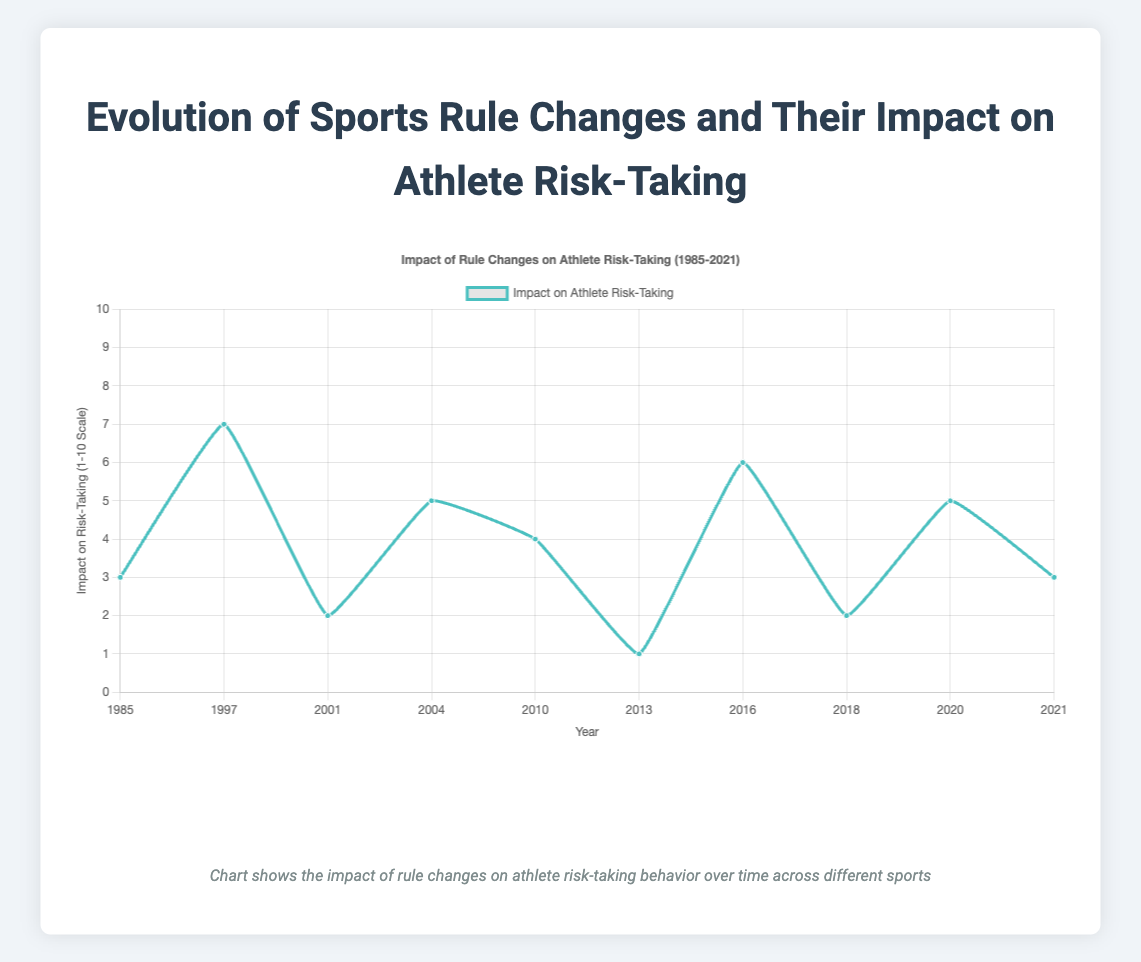What year had the highest impact on athlete risk-taking? By looking at the vertical axis (impact on risk-taking) and identifying the highest point on the line, we find that 1997 had the highest impact with a value of 7.
Answer: 1997 Which years showed a minimal impact on athlete risk-taking, and what were their respective values? From the figure, the lowest points on the curve correspond to the years 2013 and 2018, both with an impact value of 2.
Answer: 2013 and 2018, impact value 2 What is the average impact on athlete risk-taking for all the rule changes? To calculate the average, sum all the impact values and divide by the total number of data points: (3 + 7 + 2 + 5 + 4 + 1 + 6 + 2 + 5 + 3)/10 = 38/10 = 3.8
Answer: 3.8 How did the impact on athlete risk-taking change from 2001 to 2004? To find the difference, subtract the impact value of 2001 from 2004: 5 (2004) - 2 (2001) = 3.
Answer: Increased by 3 Compare the impact on athlete risk-taking between 1985 and 2021. Which was higher, and by how much? The impact value in 1985 was 3, and in 2021 it was also 3. Hence, they are equal.
Answer: They are equal What is the trend of athlete risk-taking impact from 2016 to 2018? The impact value decreased from 6 in 2016 to 2 in 2018.
Answer: Decreased What is the range of impact values on athlete risk-taking? The range is calculated by subtracting the smallest value from the largest value: 7 (highest) - 1 (lowest) = 6.
Answer: 6 Identify the year corresponding to a steady drop in athlete risk-taking impact after 2016. After 2016, there is a steady drop observed from 6 in 2016 to 2 in 2018.
Answer: 2018 What is the median impact value on athlete risk-taking? The median is the middle value when data is ordered. The ordered values are: 1, 2, 2, 3, 3, 4, 5, 5, 6, 7. The median of 10 values is the average of the 5th and 6th values: (3 + 4) / 2 = 3.5.
Answer: 3.5 